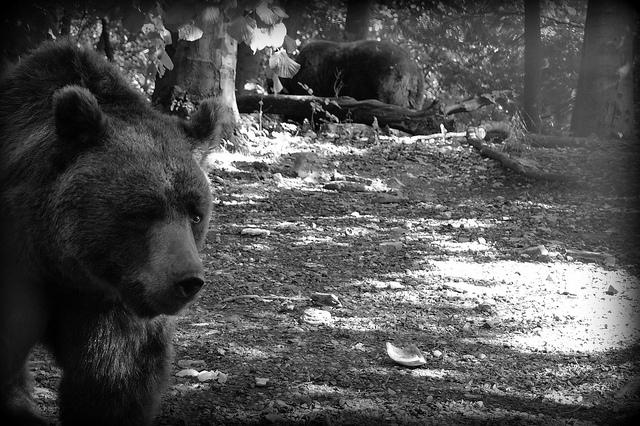What is the bear walking in?
Concise answer only. Woods. What kind of animal is this?
Give a very brief answer. Bear. Does this animal hibernate during the winter?
Concise answer only. Yes. Is the bear in a zoo?
Give a very brief answer. No. Is the bear in the water?
Answer briefly. No. 